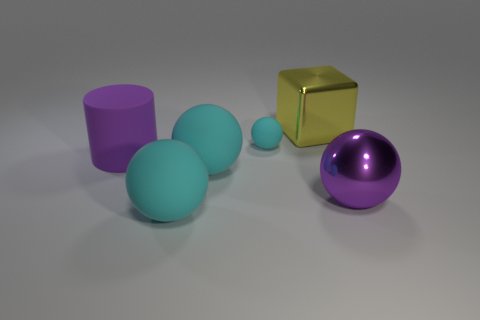Subtract all cyan balls. How many were subtracted if there are1cyan balls left? 2 Subtract all yellow cubes. How many cyan spheres are left? 3 Subtract all brown balls. Subtract all yellow cylinders. How many balls are left? 4 Add 1 big purple metallic objects. How many objects exist? 7 Subtract all blocks. How many objects are left? 5 Subtract all red spheres. Subtract all small spheres. How many objects are left? 5 Add 6 large yellow cubes. How many large yellow cubes are left? 7 Add 1 small purple cubes. How many small purple cubes exist? 1 Subtract 0 brown cylinders. How many objects are left? 6 